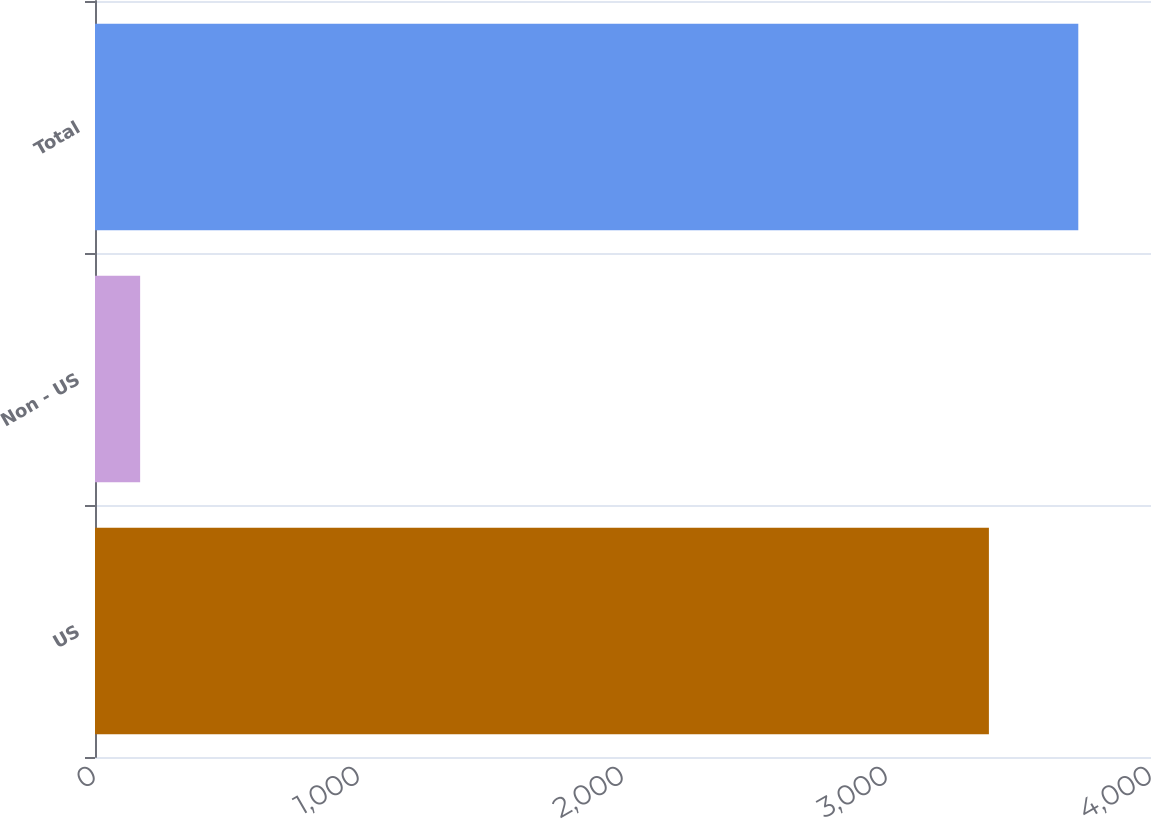<chart> <loc_0><loc_0><loc_500><loc_500><bar_chart><fcel>US<fcel>Non - US<fcel>Total<nl><fcel>3386<fcel>171<fcel>3724.6<nl></chart> 